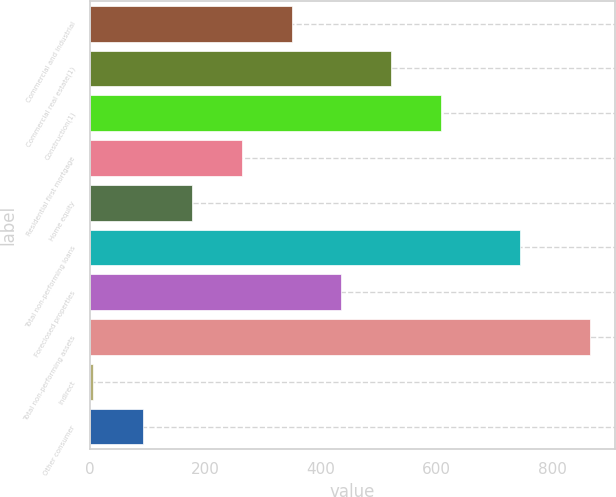Convert chart. <chart><loc_0><loc_0><loc_500><loc_500><bar_chart><fcel>Commercial and industrial<fcel>Commercial real estate(1)<fcel>Construction(1)<fcel>Residential first mortgage<fcel>Home equity<fcel>Total non-performing loans<fcel>Foreclosed properties<fcel>Total non-performing assets<fcel>Indirect<fcel>Other consumer<nl><fcel>349.2<fcel>520.8<fcel>606.6<fcel>263.4<fcel>177.6<fcel>744<fcel>435<fcel>864<fcel>6<fcel>91.8<nl></chart> 